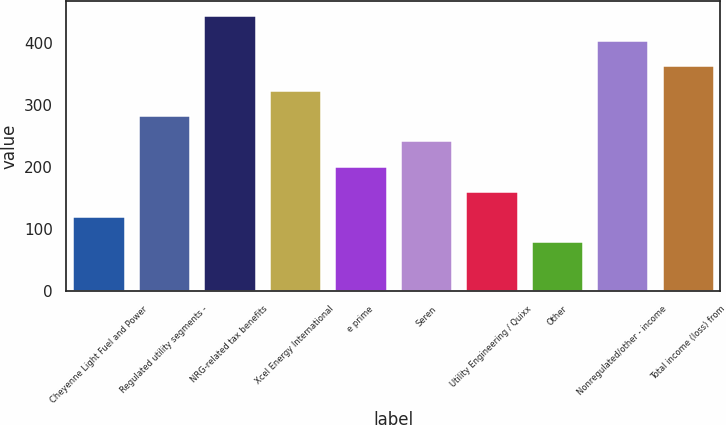Convert chart. <chart><loc_0><loc_0><loc_500><loc_500><bar_chart><fcel>Cheyenne Light Fuel and Power<fcel>Regulated utility segments -<fcel>NRG-related tax benefits<fcel>Xcel Energy International<fcel>e prime<fcel>Seren<fcel>Utility Engineering / Quixx<fcel>Other<fcel>Nonregulated/other - income<fcel>Total income (loss) from<nl><fcel>121.5<fcel>283.18<fcel>444.86<fcel>323.6<fcel>202.34<fcel>242.76<fcel>161.92<fcel>81.08<fcel>404.44<fcel>364.02<nl></chart> 